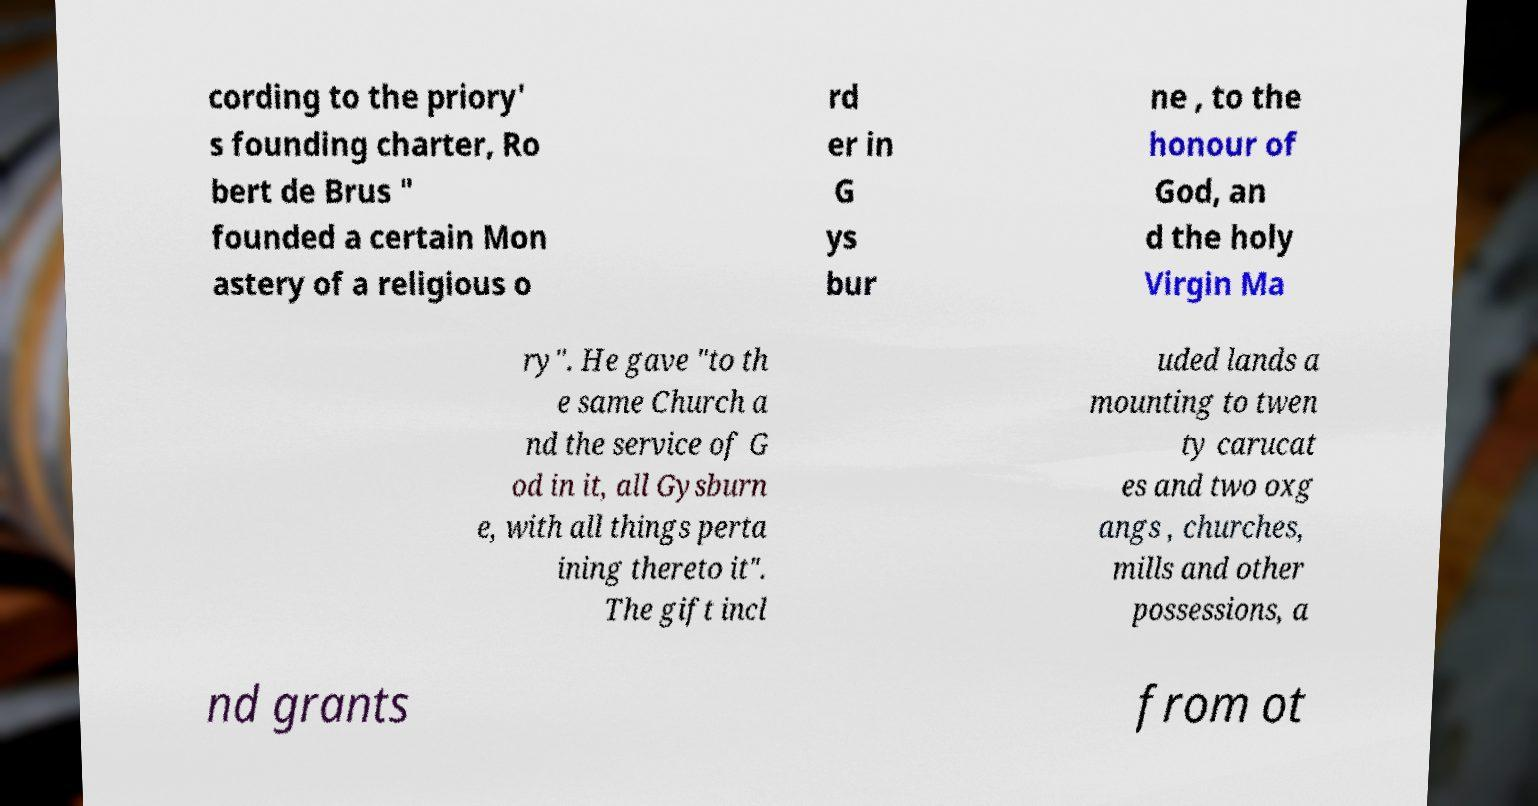I need the written content from this picture converted into text. Can you do that? cording to the priory' s founding charter, Ro bert de Brus " founded a certain Mon astery of a religious o rd er in G ys bur ne , to the honour of God, an d the holy Virgin Ma ry". He gave "to th e same Church a nd the service of G od in it, all Gysburn e, with all things perta ining thereto it". The gift incl uded lands a mounting to twen ty carucat es and two oxg angs , churches, mills and other possessions, a nd grants from ot 